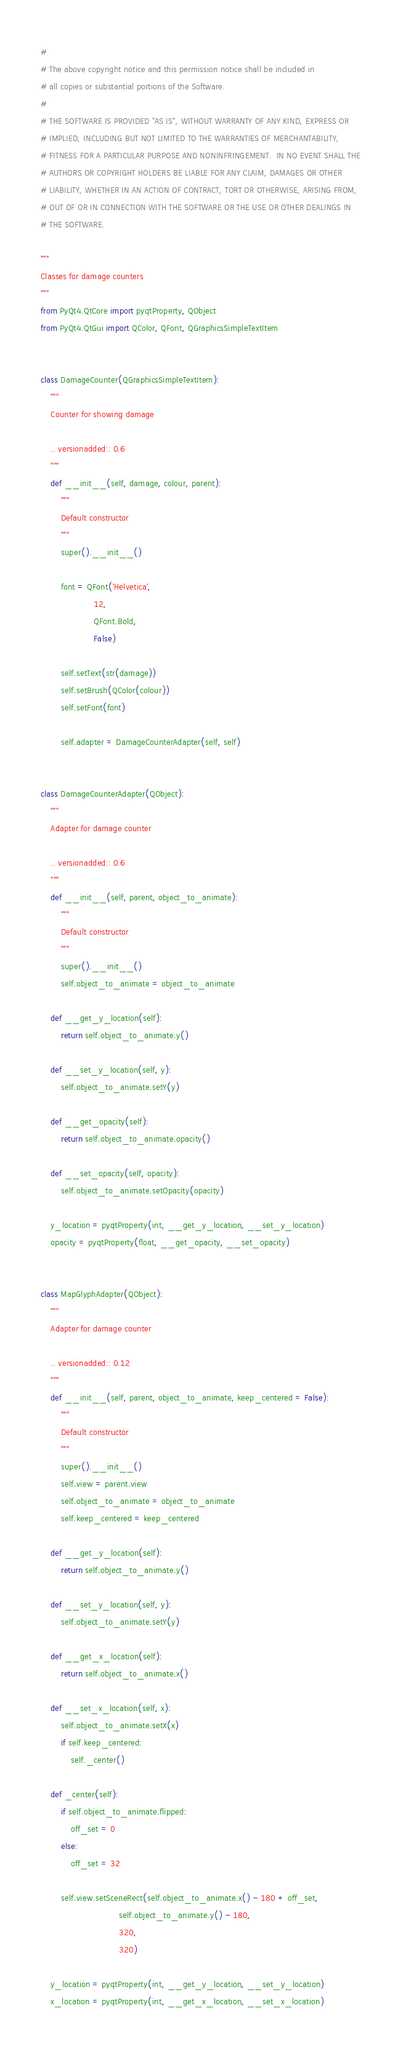<code> <loc_0><loc_0><loc_500><loc_500><_Python_># 
# The above copyright notice and this permission notice shall be included in
# all copies or substantial portions of the Software.
# 
# THE SOFTWARE IS PROVIDED "AS IS", WITHOUT WARRANTY OF ANY KIND, EXPRESS OR
# IMPLIED, INCLUDING BUT NOT LIMITED TO THE WARRANTIES OF MERCHANTABILITY,
# FITNESS FOR A PARTICULAR PURPOSE AND NONINFRINGEMENT.  IN NO EVENT SHALL THE
# AUTHORS OR COPYRIGHT HOLDERS BE LIABLE FOR ANY CLAIM, DAMAGES OR OTHER
# LIABILITY, WHETHER IN AN ACTION OF CONTRACT, TORT OR OTHERWISE, ARISING FROM,
# OUT OF OR IN CONNECTION WITH THE SOFTWARE OR THE USE OR OTHER DEALINGS IN
# THE SOFTWARE.

"""
Classes for damage counters
"""
from PyQt4.QtCore import pyqtProperty, QObject
from PyQt4.QtGui import QColor, QFont, QGraphicsSimpleTextItem


class DamageCounter(QGraphicsSimpleTextItem):
    """
    Counter for showing damage

    .. versionadded:: 0.6
    """
    def __init__(self, damage, colour, parent):
        """
        Default constructor
        """
        super().__init__()

        font = QFont('Helvetica',
                     12,
                     QFont.Bold,
                     False)

        self.setText(str(damage))
        self.setBrush(QColor(colour))
        self.setFont(font)

        self.adapter = DamageCounterAdapter(self, self)


class DamageCounterAdapter(QObject):
    """
    Adapter for damage counter

    .. versionadded:: 0.6
    """
    def __init__(self, parent, object_to_animate):
        """
        Default constructor
        """
        super().__init__()
        self.object_to_animate = object_to_animate

    def __get_y_location(self):
        return self.object_to_animate.y()

    def __set_y_location(self, y):
        self.object_to_animate.setY(y)

    def __get_opacity(self):
        return self.object_to_animate.opacity()

    def __set_opacity(self, opacity):
        self.object_to_animate.setOpacity(opacity)

    y_location = pyqtProperty(int, __get_y_location, __set_y_location)
    opacity = pyqtProperty(float, __get_opacity, __set_opacity)


class MapGlyphAdapter(QObject):
    """
    Adapter for damage counter

    .. versionadded:: 0.12
    """
    def __init__(self, parent, object_to_animate, keep_centered = False):
        """
        Default constructor
        """
        super().__init__()
        self.view = parent.view
        self.object_to_animate = object_to_animate
        self.keep_centered = keep_centered

    def __get_y_location(self):
        return self.object_to_animate.y()

    def __set_y_location(self, y):
        self.object_to_animate.setY(y)

    def __get_x_location(self):
        return self.object_to_animate.x()

    def __set_x_location(self, x):
        self.object_to_animate.setX(x)
        if self.keep_centered:
            self._center()

    def _center(self):
        if self.object_to_animate.flipped:
            off_set = 0
        else:
            off_set = 32

        self.view.setSceneRect(self.object_to_animate.x() - 180 + off_set,
                               self.object_to_animate.y() - 180,
                               320,
                               320)

    y_location = pyqtProperty(int, __get_y_location, __set_y_location)
    x_location = pyqtProperty(int, __get_x_location, __set_x_location)
</code> 